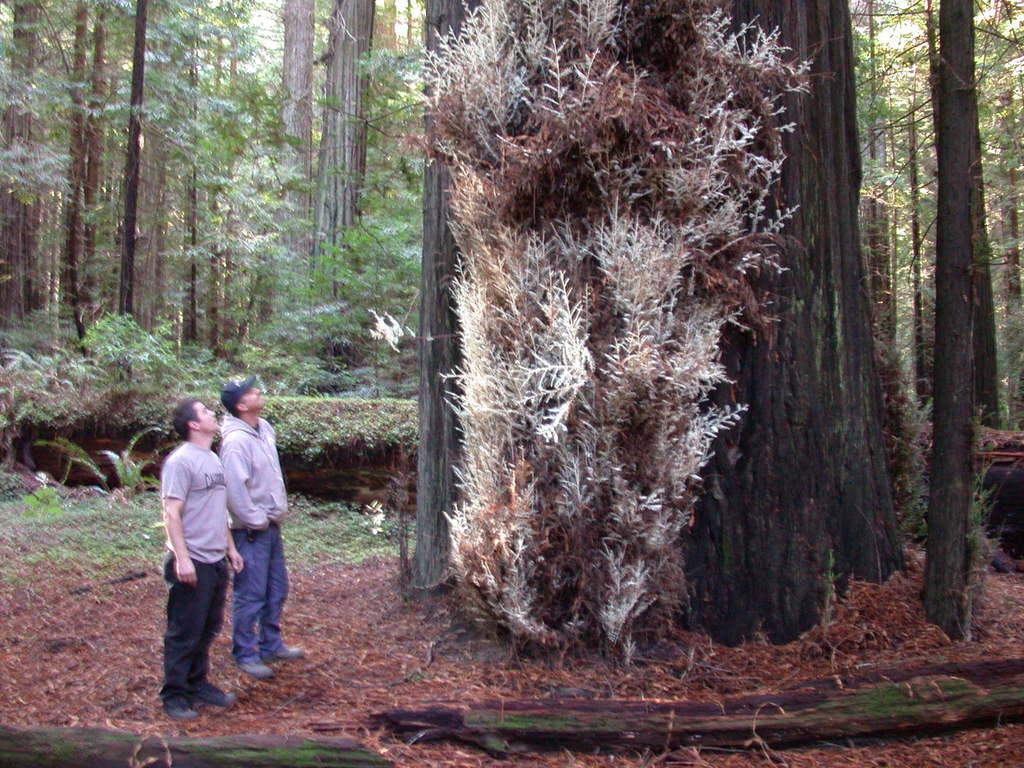What can be seen on the left side of the image? There are persons standing on the ground on the left side of the image. What is located in the center of the image? There is a tree in the center of the image. What is visible in the background of the image? There are trees and plants visible in the background of the image. What type of jar is being used to extinguish the fire in the image? There is no fire or jar present in the image. How many arms does the tree in the center of the image have? Trees do not have arms; they have branches. The tree in the image has multiple branches, but it is not accurate to describe them as arms. 